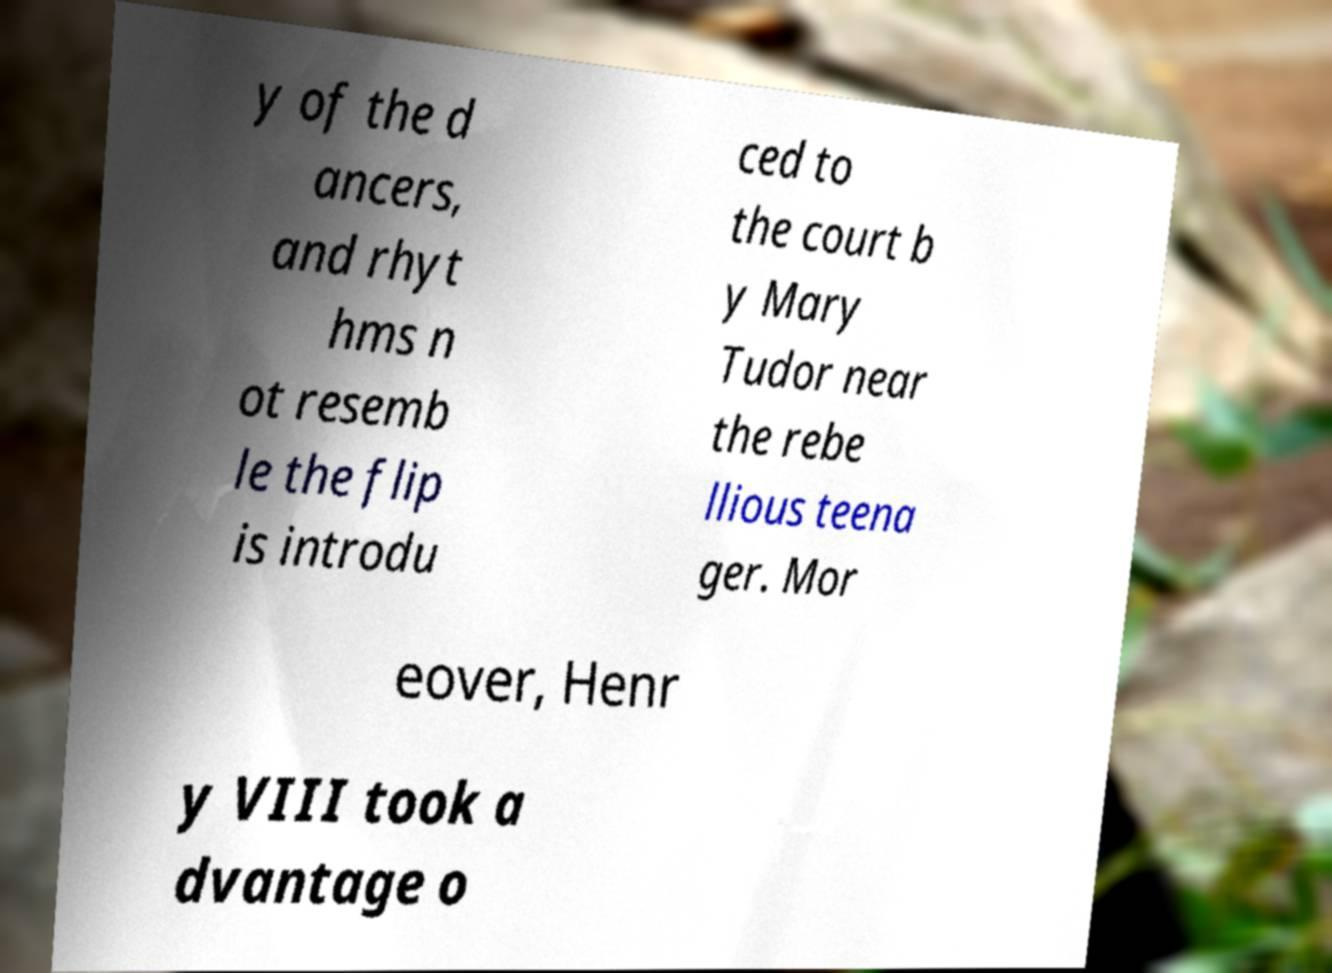Please identify and transcribe the text found in this image. y of the d ancers, and rhyt hms n ot resemb le the flip is introdu ced to the court b y Mary Tudor near the rebe llious teena ger. Mor eover, Henr y VIII took a dvantage o 